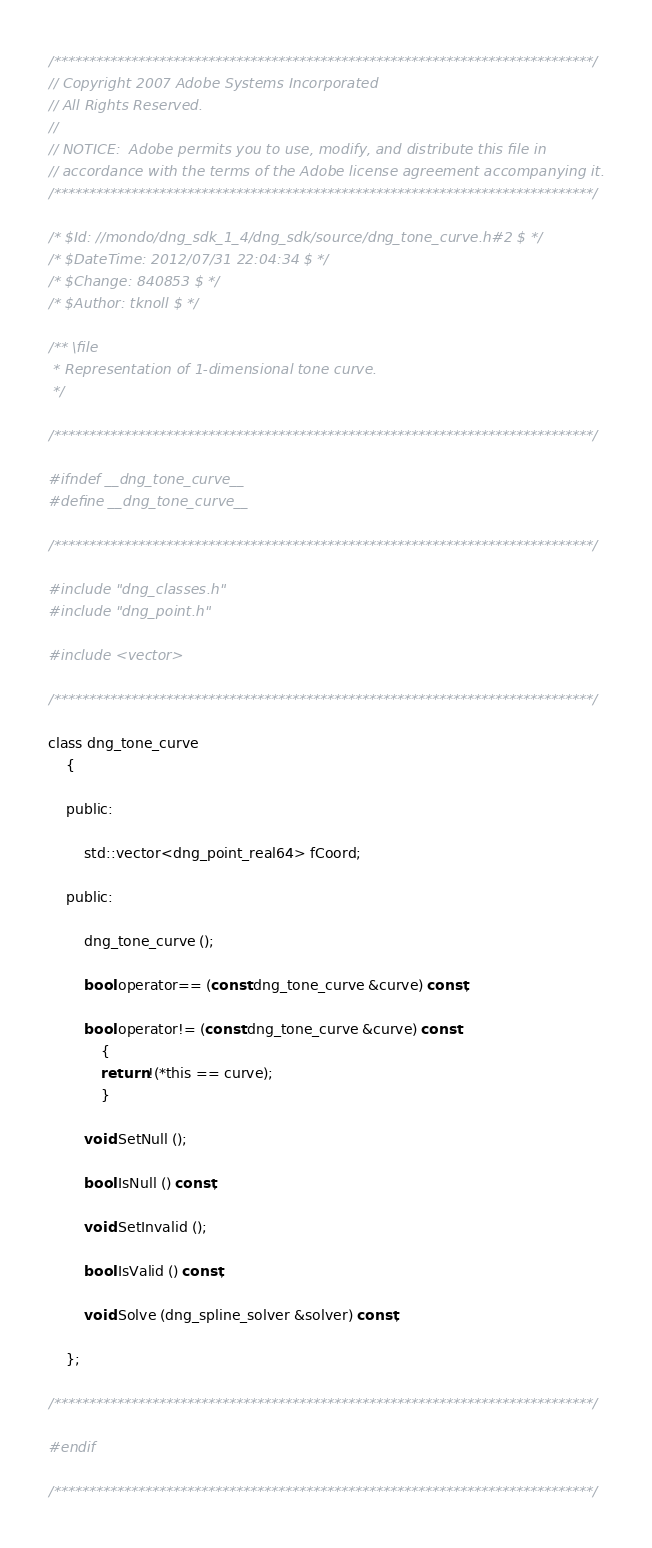<code> <loc_0><loc_0><loc_500><loc_500><_C_>/*****************************************************************************/
// Copyright 2007 Adobe Systems Incorporated
// All Rights Reserved.
//
// NOTICE:  Adobe permits you to use, modify, and distribute this file in
// accordance with the terms of the Adobe license agreement accompanying it.
/*****************************************************************************/

/* $Id: //mondo/dng_sdk_1_4/dng_sdk/source/dng_tone_curve.h#2 $ */ 
/* $DateTime: 2012/07/31 22:04:34 $ */
/* $Change: 840853 $ */
/* $Author: tknoll $ */

/** \file
 * Representation of 1-dimensional tone curve.
 */

/*****************************************************************************/

#ifndef __dng_tone_curve__
#define __dng_tone_curve__

/*****************************************************************************/

#include "dng_classes.h"
#include "dng_point.h"

#include <vector>

/*****************************************************************************/

class dng_tone_curve
	{
	
	public:
		
		std::vector<dng_point_real64> fCoord;
		
	public:

		dng_tone_curve ();

		bool operator== (const dng_tone_curve &curve) const;
		
		bool operator!= (const dng_tone_curve &curve) const
			{
			return !(*this == curve);
			}
			
		void SetNull ();

		bool IsNull () const;
		
		void SetInvalid ();
		
		bool IsValid () const;
		
		void Solve (dng_spline_solver &solver) const;
		
	};

/*****************************************************************************/

#endif

/*****************************************************************************/
</code> 